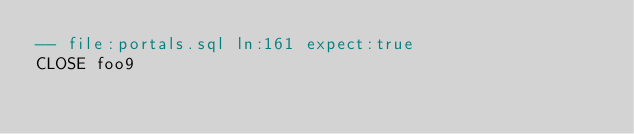<code> <loc_0><loc_0><loc_500><loc_500><_SQL_>-- file:portals.sql ln:161 expect:true
CLOSE foo9
</code> 